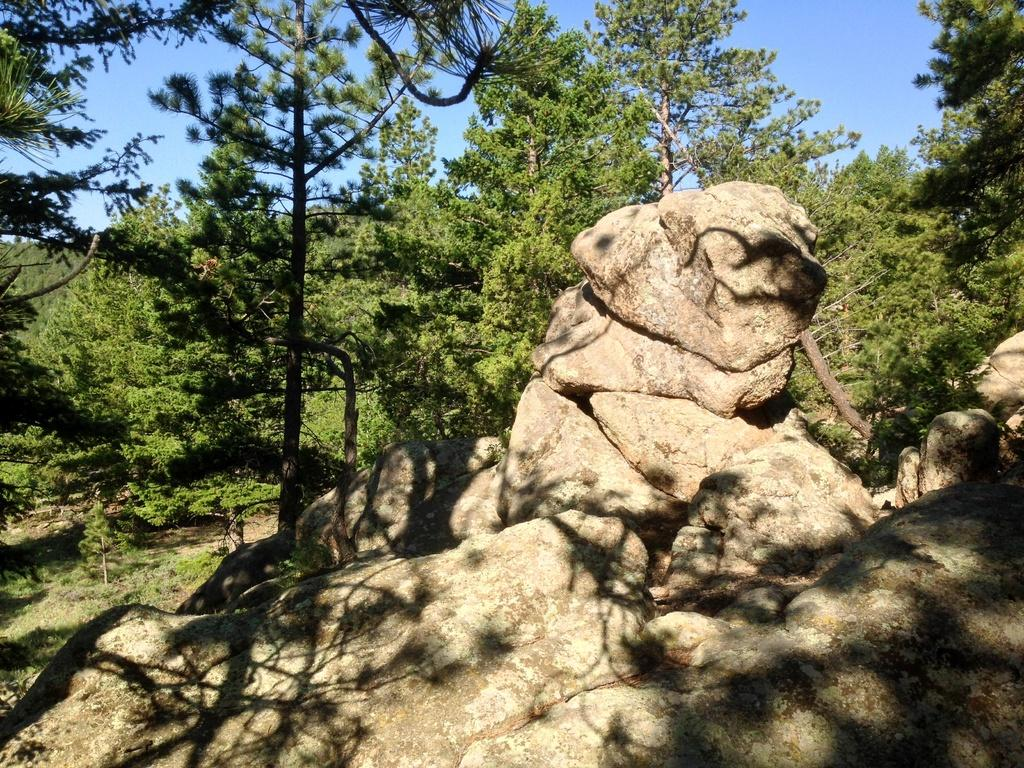What is the main subject in the middle of the image? There is a brown color mountain in the middle of the image. What can be seen in the background of the image? There are many trees visible in the background. How would you describe the sky in the image? The sky is blue and clear. What type of organization is responsible for maintaining the needle in the image? There is no needle present in the image, so there is no organization responsible for maintaining it. 